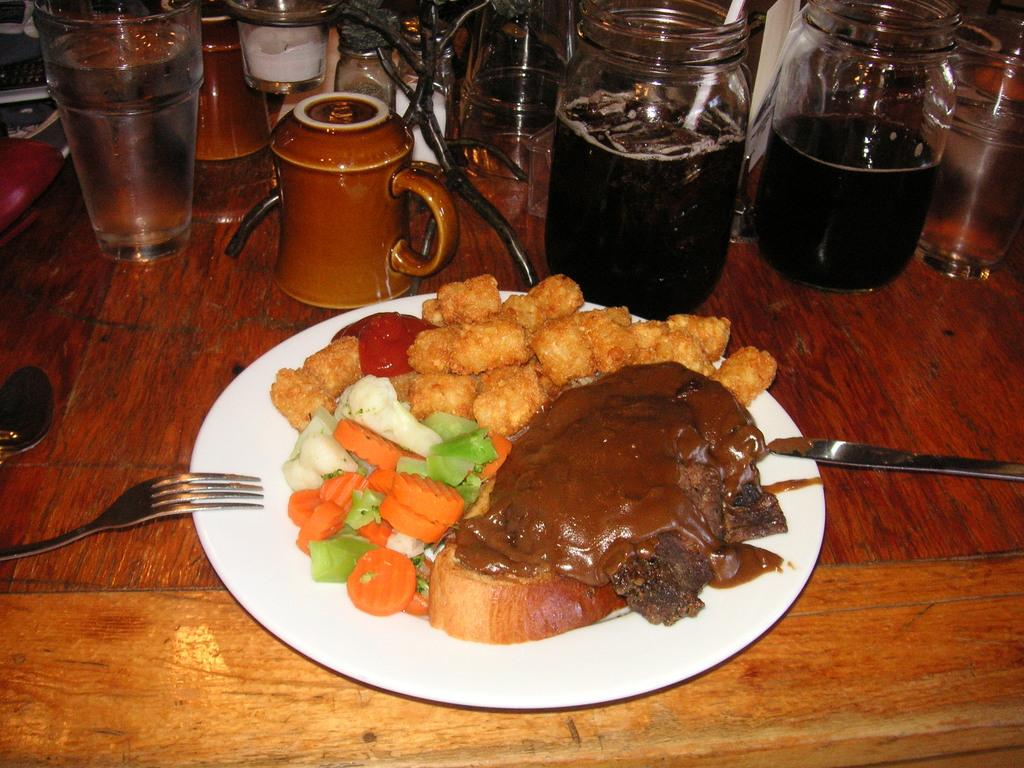What is on the plate that is visible in the image? There is food placed on a plate in the image. What utensils are present on the table in the image? There are spoons on the table in the image. What can be seen in the background of the image? There is a group of glasses, bottles, and cups in the background of the image. How many chickens are present in the image? There are no chickens present in the image. What type of shock can be seen in the image? There is no shock present in the image. 